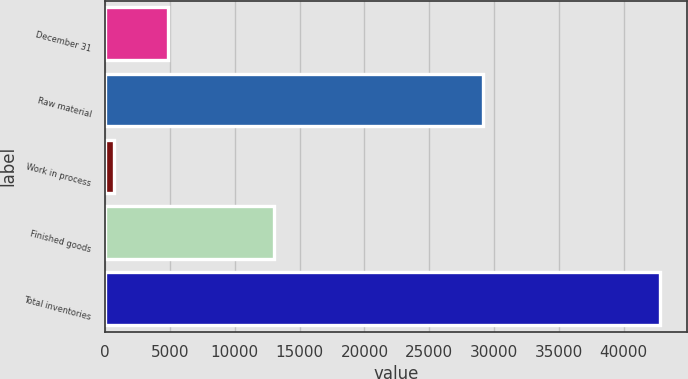Convert chart. <chart><loc_0><loc_0><loc_500><loc_500><bar_chart><fcel>December 31<fcel>Raw material<fcel>Work in process<fcel>Finished goods<fcel>Total inventories<nl><fcel>4858.6<fcel>29127<fcel>645<fcel>13009<fcel>42781<nl></chart> 